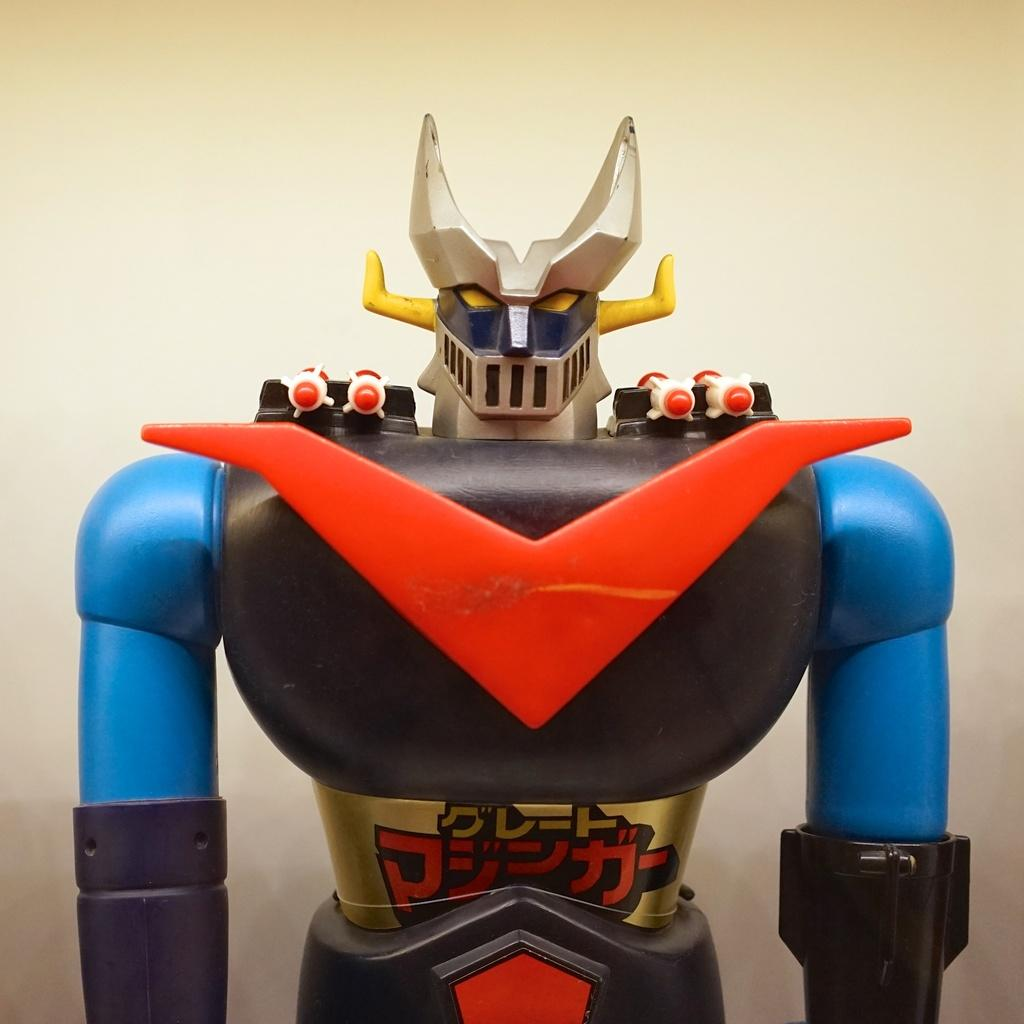What object can be seen in the image? There is a toy in the image. What color is the background of the image? The background of the image is cream-colored. How many ladybugs are crawling on the toy in the image? There are no ladybugs present in the image; it only features a toy and a cream-colored background. 